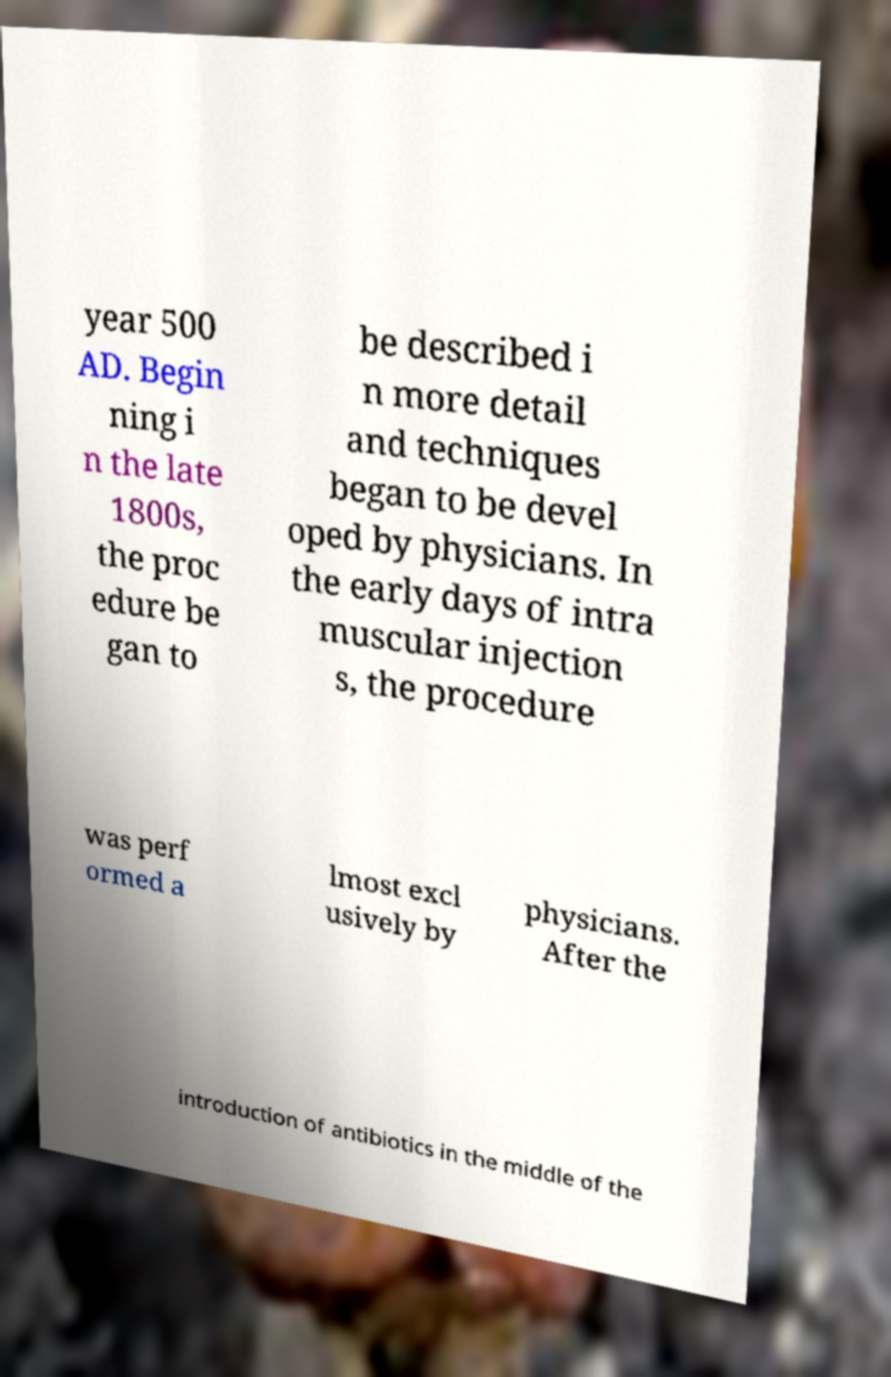For documentation purposes, I need the text within this image transcribed. Could you provide that? year 500 AD. Begin ning i n the late 1800s, the proc edure be gan to be described i n more detail and techniques began to be devel oped by physicians. In the early days of intra muscular injection s, the procedure was perf ormed a lmost excl usively by physicians. After the introduction of antibiotics in the middle of the 